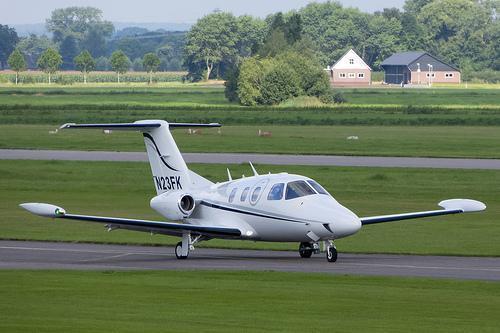How many landing strips are there?
Give a very brief answer. 2. 